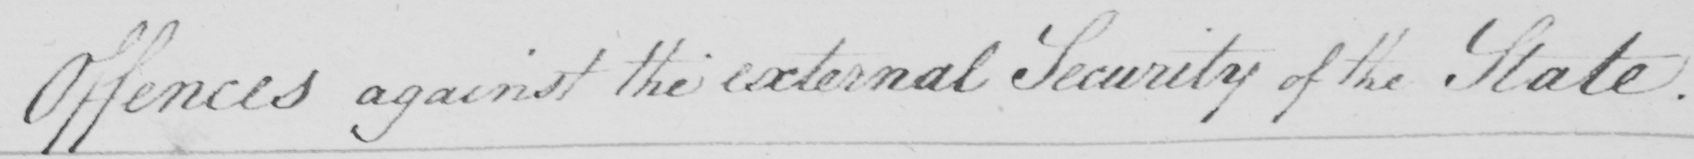Can you tell me what this handwritten text says? Offences against the external Security of the State . 